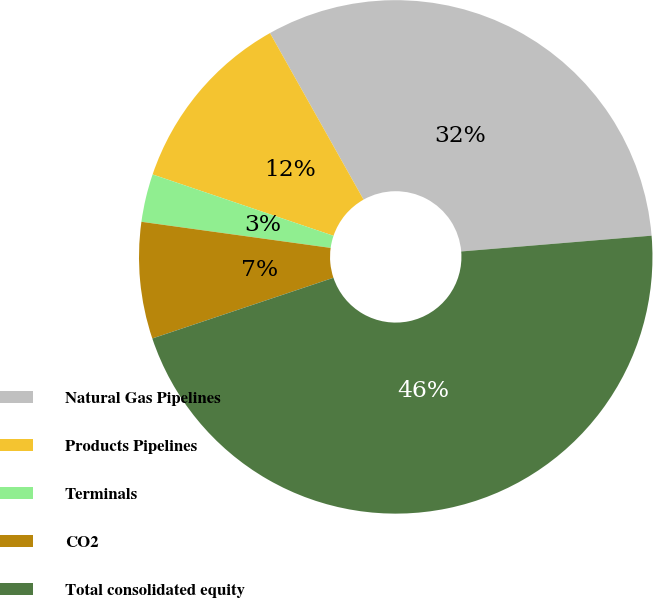Convert chart to OTSL. <chart><loc_0><loc_0><loc_500><loc_500><pie_chart><fcel>Natural Gas Pipelines<fcel>Products Pipelines<fcel>Terminals<fcel>CO2<fcel>Total consolidated equity<nl><fcel>31.83%<fcel>11.65%<fcel>3.02%<fcel>7.33%<fcel>46.17%<nl></chart> 